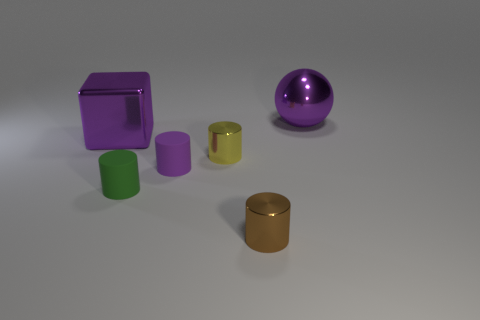Subtract all blue balls. Subtract all brown cylinders. How many balls are left? 1 Add 4 yellow metallic cylinders. How many objects exist? 10 Subtract all cylinders. How many objects are left? 2 Subtract 0 brown blocks. How many objects are left? 6 Subtract all purple things. Subtract all big purple rubber objects. How many objects are left? 3 Add 1 rubber things. How many rubber things are left? 3 Add 6 purple blocks. How many purple blocks exist? 7 